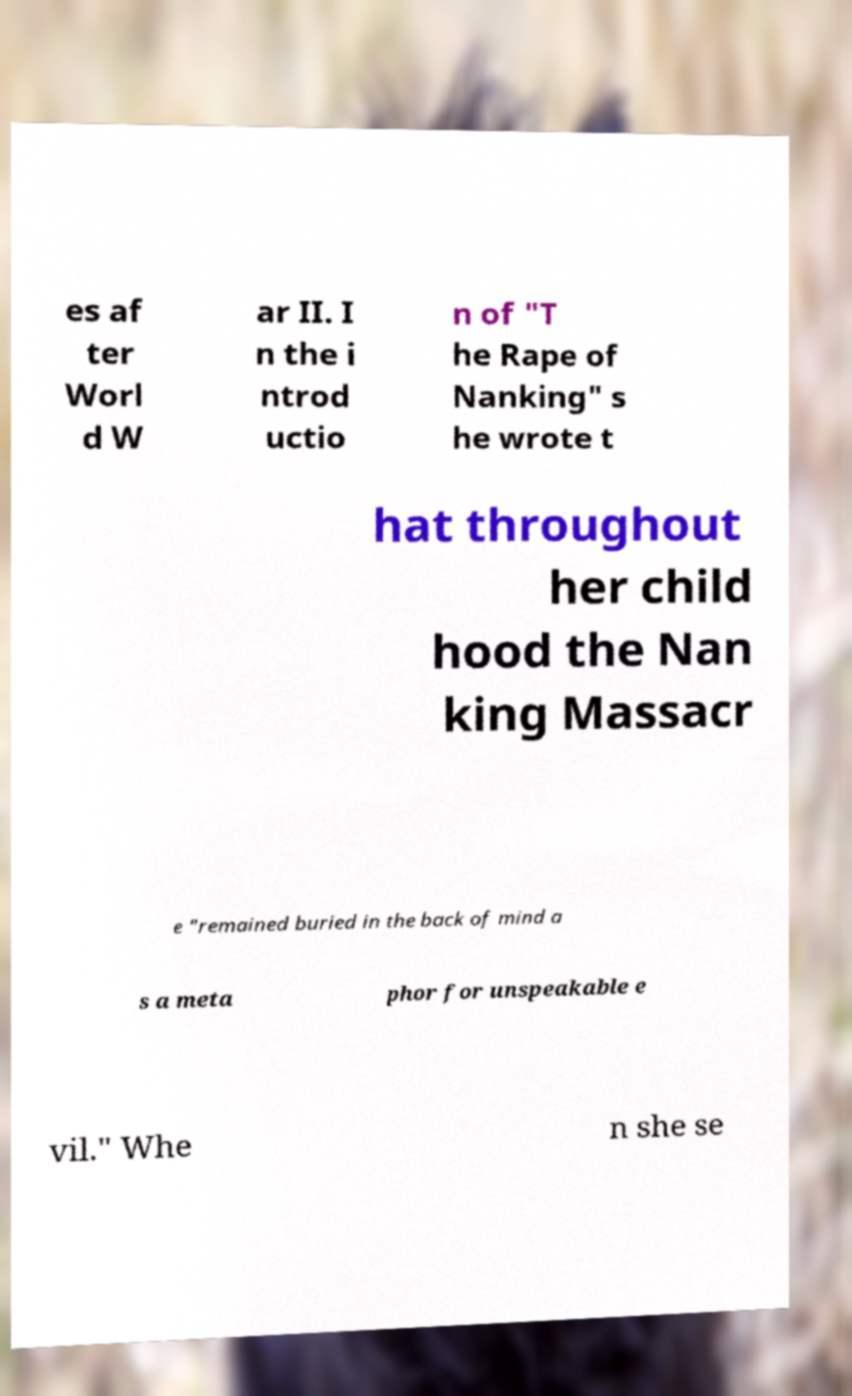Please read and relay the text visible in this image. What does it say? es af ter Worl d W ar II. I n the i ntrod uctio n of "T he Rape of Nanking" s he wrote t hat throughout her child hood the Nan king Massacr e "remained buried in the back of mind a s a meta phor for unspeakable e vil." Whe n she se 